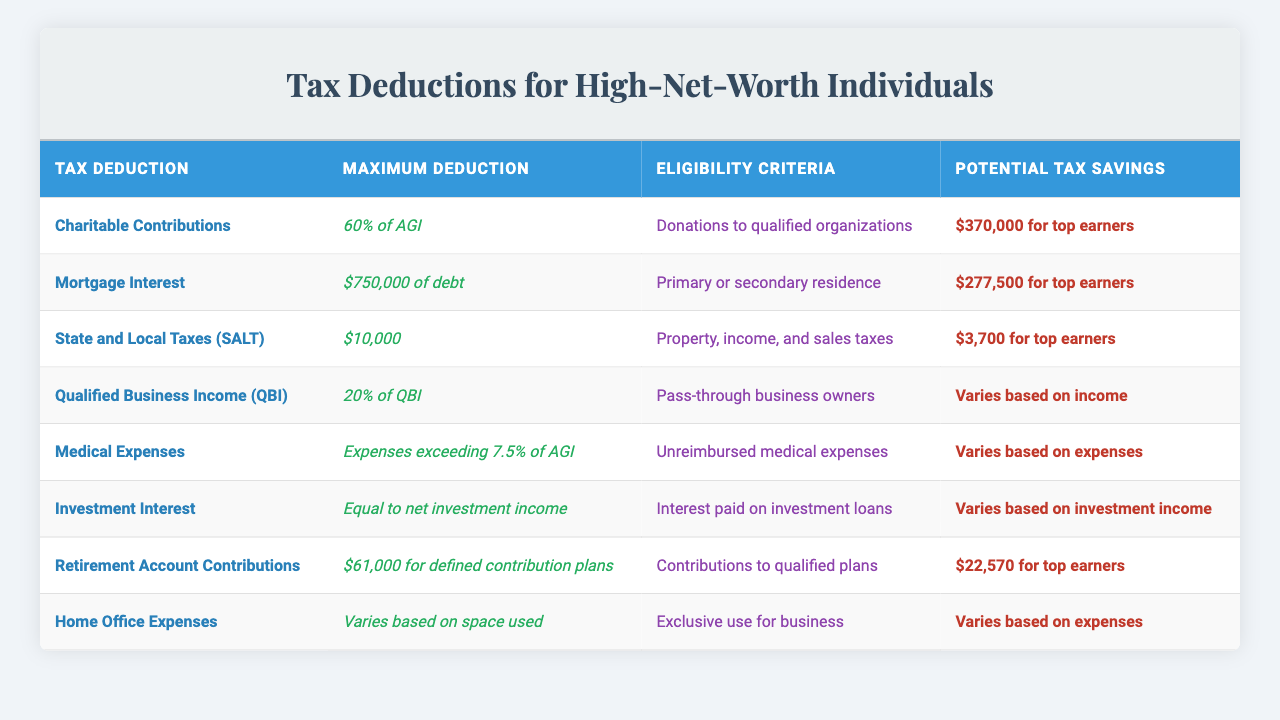What is the maximum deduction for Charitable Contributions? The maximum deduction listed for Charitable Contributions is 60% of AGI.
Answer: 60% of AGI What are the eligibility criteria for Mortgage Interest deductions? The eligibility criteria for Mortgage Interest deductions is that it should be on a primary or secondary residence.
Answer: Primary or secondary residence If a high-net-worth individual donates $1 million to a qualified organization, what would be the maximum potential tax savings from this deduction? Since the maximum deduction for Charitable Contributions is 60% of AGI, for a $1 million donation, the maximum deduction would be $600,000, and for top earners, the potential tax savings would be $370,000.
Answer: $370,000 Is the potential tax savings for State and Local Taxes (SALT) the same for all individuals? No, the potential tax savings for State and Local Taxes (SALT) is stated as $3,700 for top earners, indicating it may vary for others based on their income levels.
Answer: No What is the total maximum deduction possible combining Charitable Contributions and Mortgage Interest for a high-net-worth individual? The maximum deduction for Charitable Contributions is 60% of AGI, while for Mortgage Interest, it's $750,000. Therefore, to find the total, one would need to know the specific AGI to quantify it, but structurally, it will be 60% of AGI + $750,000.
Answer: 60% of AGI + $750,000 For a pass-through business owner, what percentage of Qualified Business Income (QBI) is deductible? The deduction for Qualified Business Income (QBI) is 20% of the QBI.
Answer: 20% If a high-net-worth individual has $500,000 in investment income, what would be their maximum potential tax savings from Investment Interest deductions? According to the table, the maximum deduction for Investment Interest is equal to net investment income; hence, if the individual has $500,000 in investment income, their maximum potential tax savings would also be $500,000, as it varies based on investment income.
Answer: $500,000 What is the maximum deduction for Retirement Account Contributions? The maximum deduction for Retirement Account Contributions is $61,000 for defined contribution plans.
Answer: $61,000 Can someone deduct Home Office Expenses if the space is not used exclusively for business? No, the eligibility criteria for Home Office Expenses requires the space to be used exclusively for business to qualify for deductions.
Answer: No What could be the potential tax savings if a high-net-worth individual has unreimbursed medical expenses of $200,000? Since the maximum deduction for medical expenses is those exceeding 7.5% of AGI, one would first need to know the AGI. For example, if AGI is $2 million, 7.5% would be $150,000, and the deductible amount would be $50,000, but potential savings would require tax rate information. Thus, it can't be definitively answered without additional data.
Answer: Varies based on AGI and expenses 